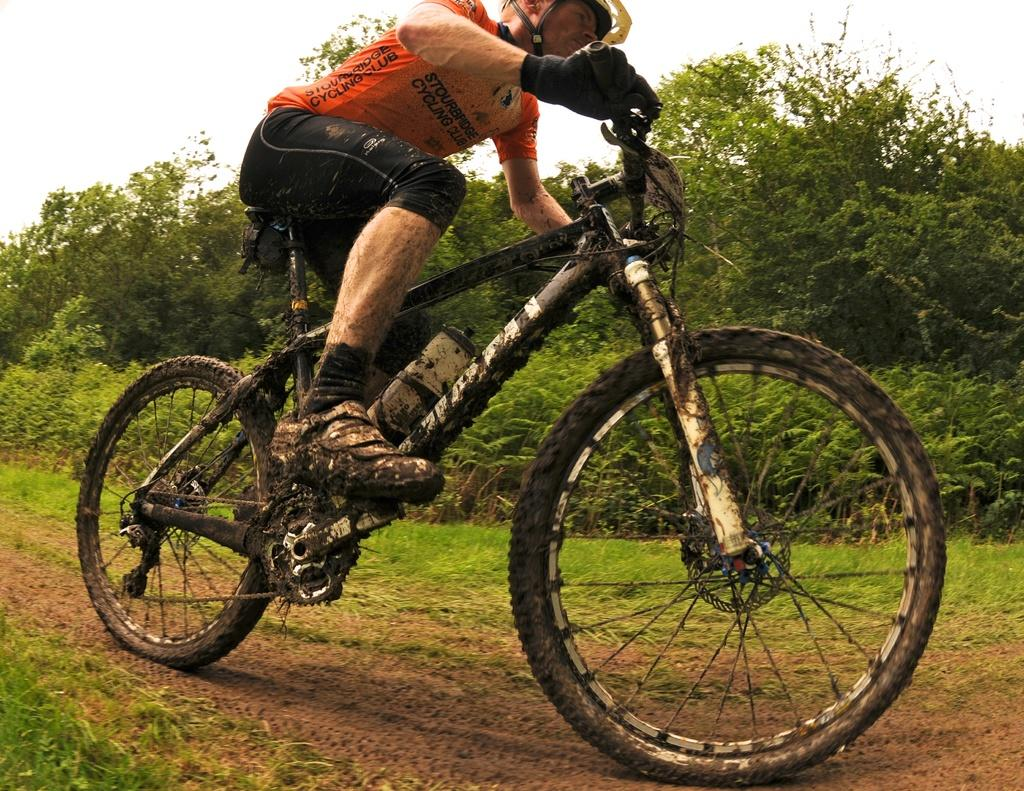<image>
Describe the image concisely. A guy riding a bike with a shirt that says STOURBRIDGE CYCLING CLUB. 